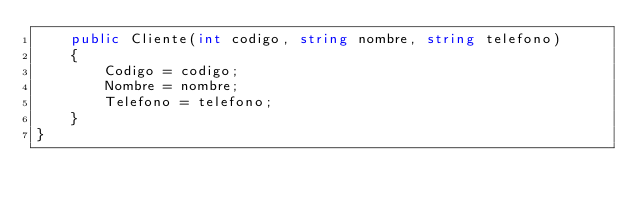Convert code to text. <code><loc_0><loc_0><loc_500><loc_500><_C#_>    public Cliente(int codigo, string nombre, string telefono)
    {
        Codigo = codigo;
        Nombre = nombre;
        Telefono = telefono;
    }
}</code> 